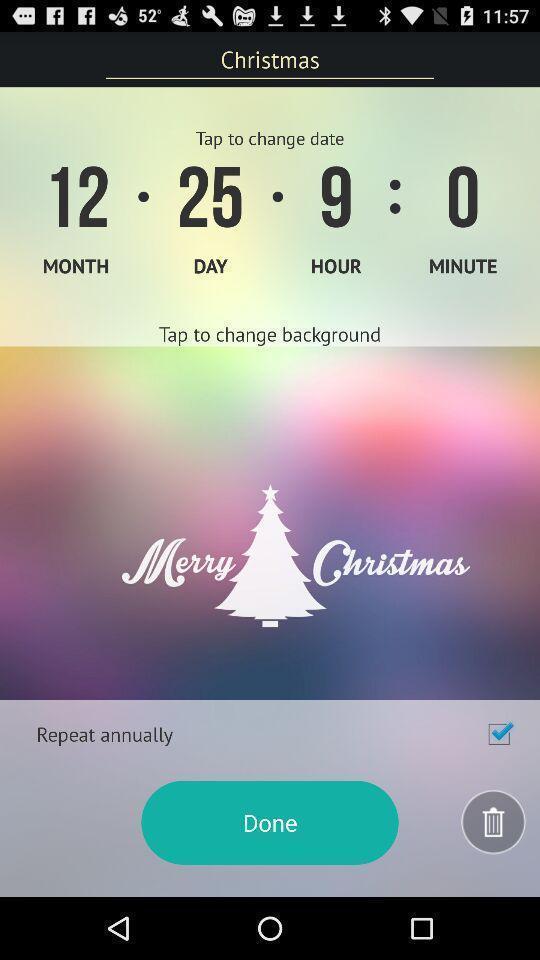Provide a textual representation of this image. Window displaying a countdown calendar. 